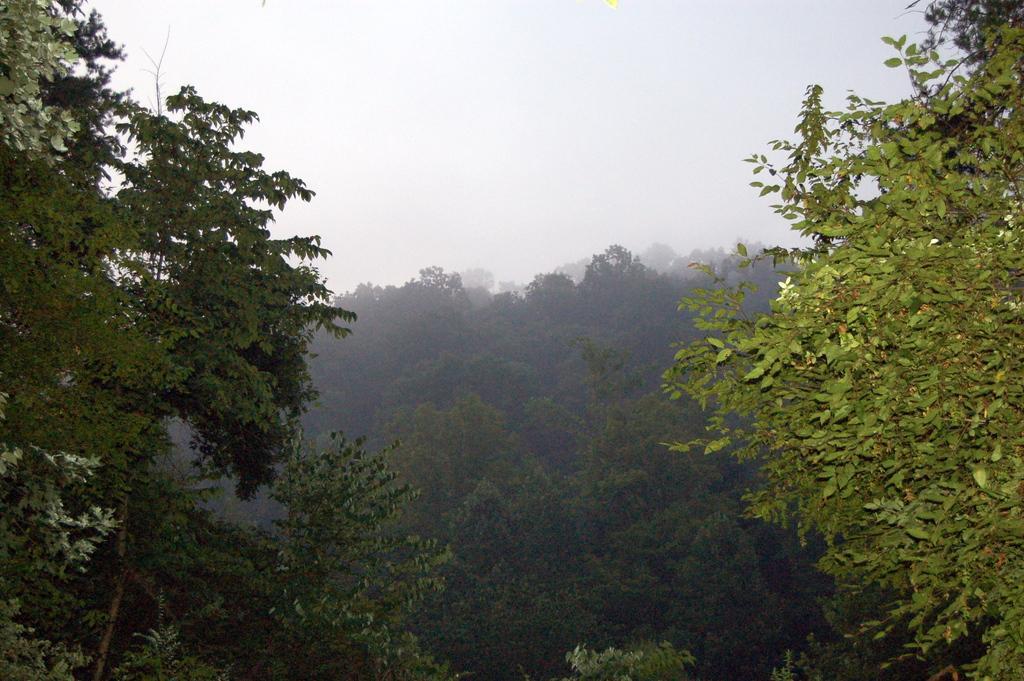Could you give a brief overview of what you see in this image? In this picture we can see trees and in the background we can see the sky. 